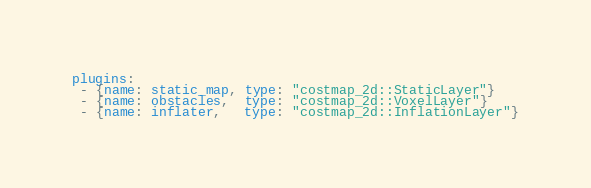<code> <loc_0><loc_0><loc_500><loc_500><_YAML_>plugins:
 - {name: static_map, type: "costmap_2d::StaticLayer"}
 - {name: obstacles,  type: "costmap_2d::VoxelLayer"}
 - {name: inflater,   type: "costmap_2d::InflationLayer"}
</code> 